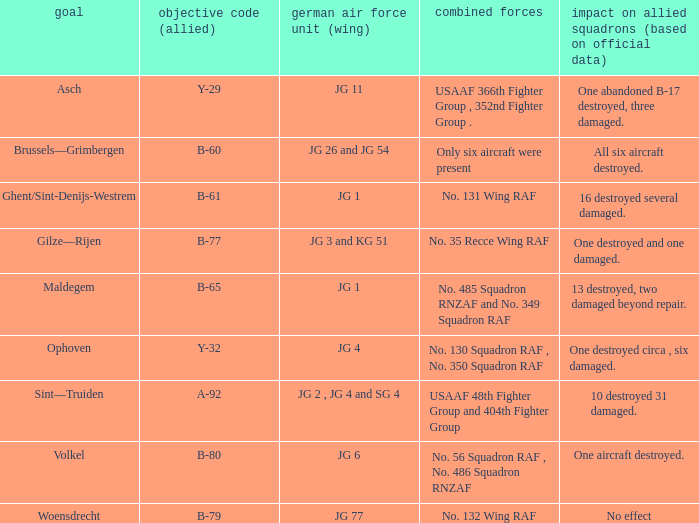What is the allied target code of the group that targetted ghent/sint-denijs-westrem? B-61. 